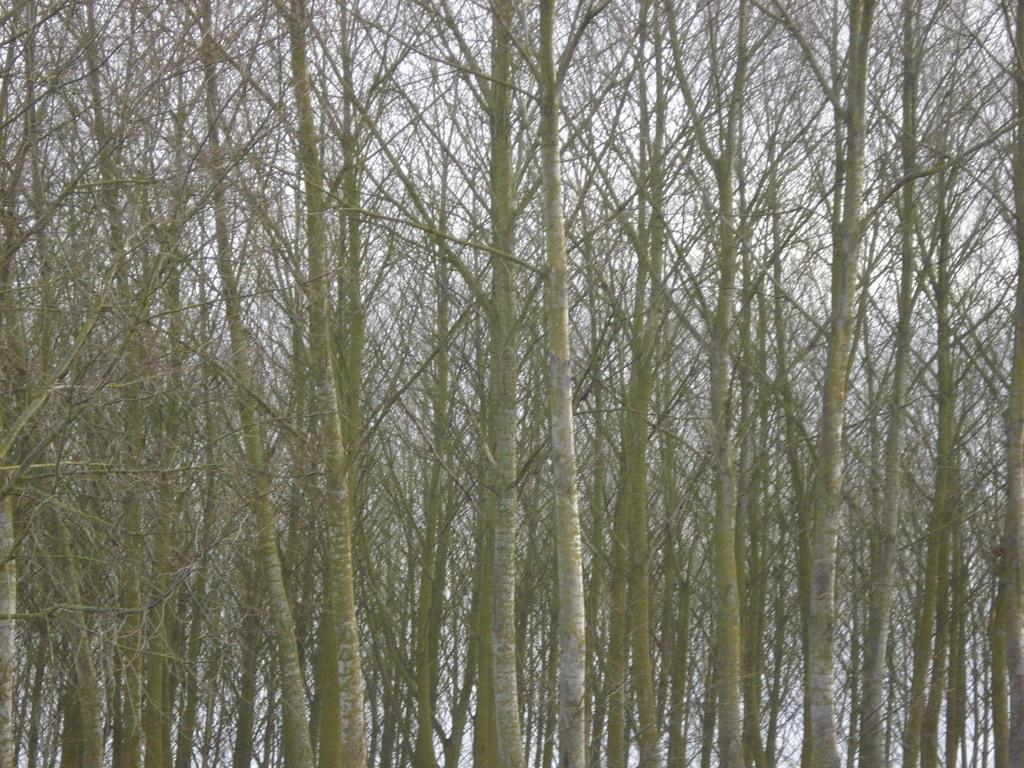What type of trees can be seen in the image? There are long branch trees in the image. What part of the natural environment is visible in the image? The sky is partially visible in the image. What type of nail is being used by the judge in the image? There is no judge or nail present in the image; it features long branch trees and a partially visible sky. 